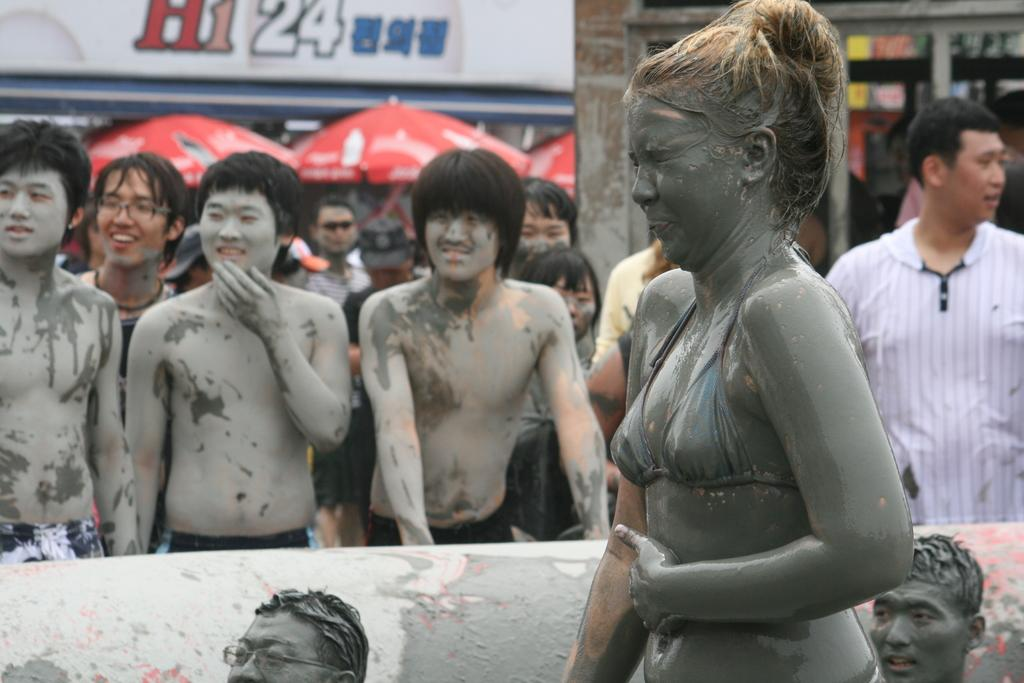What is the condition of the people in the image? There are people covered with mud in the image. Are there any other people visible in the image? Yes, there are other people in the image. What can be seen in the background of the image? There are red umbrellas and buildings in the background of the image. Can you describe the lady in the foreground of the image? There is a lady in the foreground of the image. How many toys can be seen in the image? There are no toys present in the image. What type of lumber is being used to construct the buildings in the image? There is no information about the type of lumber used in the construction of the buildings in the image. 